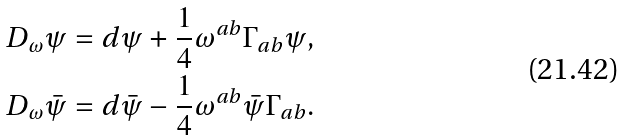<formula> <loc_0><loc_0><loc_500><loc_500>D _ { \omega } \psi & = d \psi + \frac { 1 } { 4 } \omega ^ { a b } \Gamma _ { a b } \psi , \\ D _ { \omega } \bar { \psi } & = d \bar { \psi } - \frac { 1 } { 4 } \omega ^ { a b } \bar { \psi } \Gamma _ { a b } .</formula> 